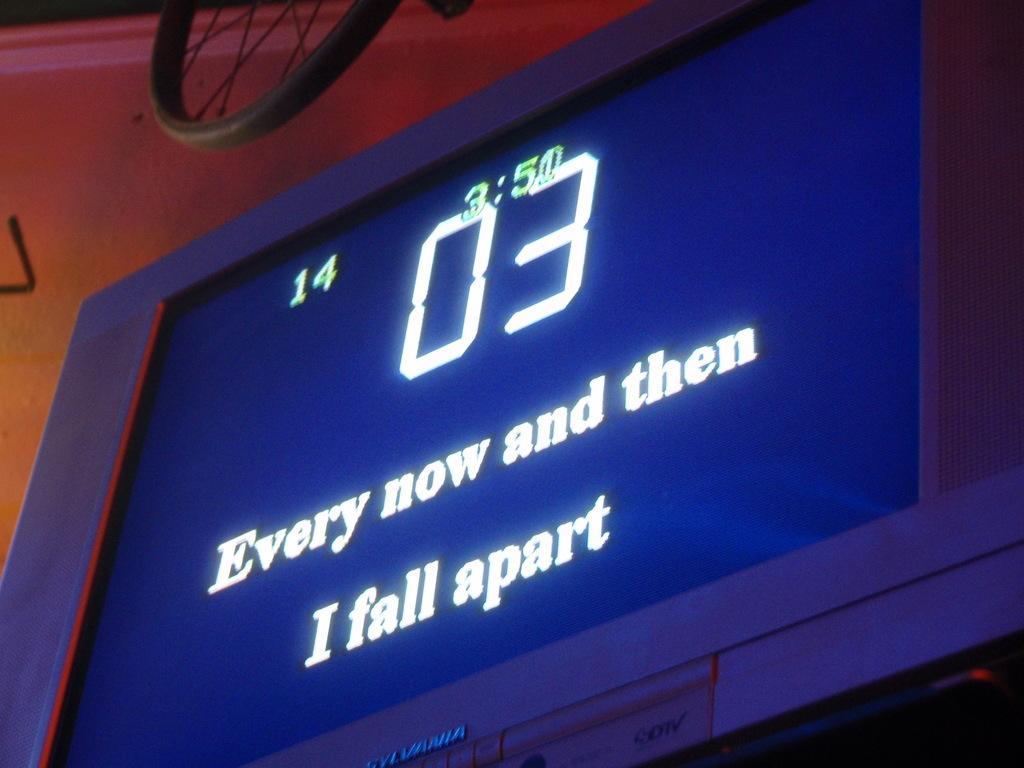<image>
Summarize the visual content of the image. A tv screen that has the lyrics every now and then I fall apart. 